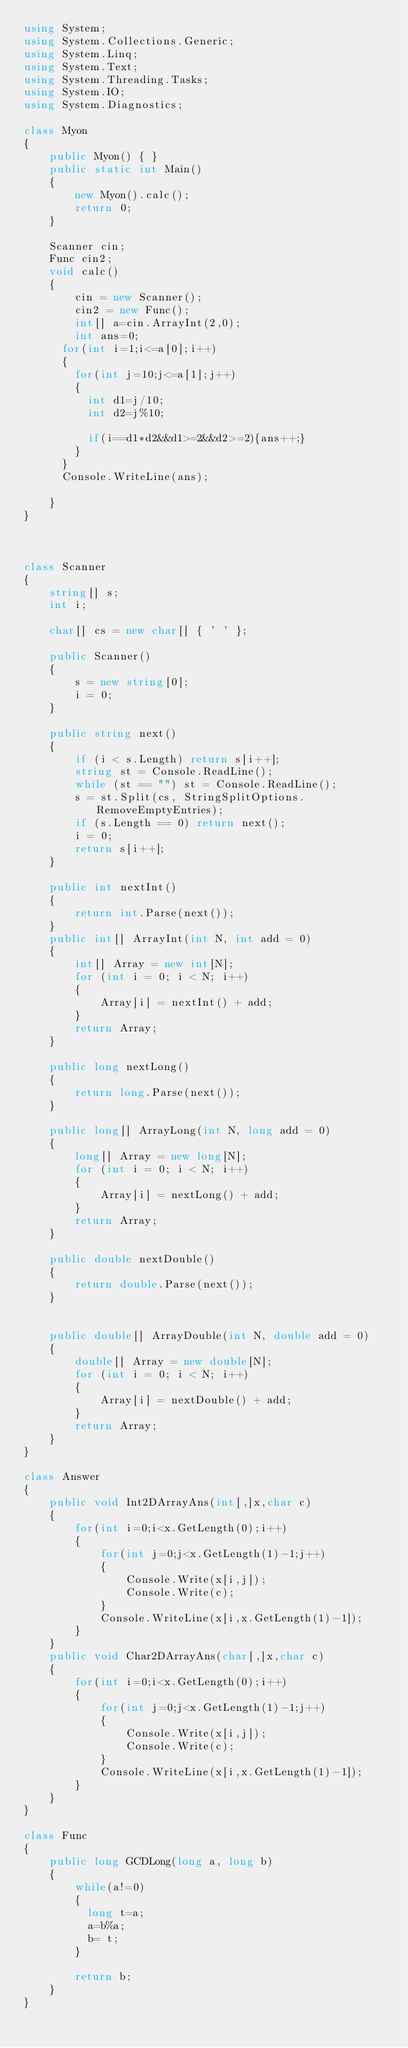Convert code to text. <code><loc_0><loc_0><loc_500><loc_500><_C#_>using System;
using System.Collections.Generic;
using System.Linq;
using System.Text;
using System.Threading.Tasks;
using System.IO;
using System.Diagnostics;

class Myon
{
    public Myon() { }
    public static int Main()
    {
        new Myon().calc();
        return 0;
    }

    Scanner cin;
    Func cin2;
    void calc()
    {
        cin = new Scanner();
        cin2 = new Func();
        int[] a=cin.ArrayInt(2,0);
        int ans=0;
      for(int i=1;i<=a[0];i++)
      {
        for(int j=10;j<=a[1];j++)
        {
          int d1=j/10;
          int d2=j%10;
          
          if(i==d1*d2&&d1>=2&&d2>=2){ans++;}
        }
      }
      Console.WriteLine(ans);
        
    }
}



class Scanner
{
    string[] s;
    int i;

    char[] cs = new char[] { ' ' };

    public Scanner()
    {
        s = new string[0];
        i = 0;
    }

    public string next()
    {
        if (i < s.Length) return s[i++];
        string st = Console.ReadLine();
        while (st == "") st = Console.ReadLine();
        s = st.Split(cs, StringSplitOptions.RemoveEmptyEntries);
        if (s.Length == 0) return next();
        i = 0;
        return s[i++];
    }

    public int nextInt()
    {
        return int.Parse(next());
    }
    public int[] ArrayInt(int N, int add = 0)
    {
        int[] Array = new int[N];
        for (int i = 0; i < N; i++)
        {
            Array[i] = nextInt() + add;
        }
        return Array;
    }

    public long nextLong()
    {
        return long.Parse(next());
    }

    public long[] ArrayLong(int N, long add = 0)
    {
        long[] Array = new long[N];
        for (int i = 0; i < N; i++)
        {
            Array[i] = nextLong() + add;
        }
        return Array;
    }

    public double nextDouble()
    {
        return double.Parse(next());
    }


    public double[] ArrayDouble(int N, double add = 0)
    {
        double[] Array = new double[N];
        for (int i = 0; i < N; i++)
        {
            Array[i] = nextDouble() + add;
        }
        return Array;
    }
}

class Answer
{
    public void Int2DArrayAns(int[,]x,char c)
    {
        for(int i=0;i<x.GetLength(0);i++)
        {
            for(int j=0;j<x.GetLength(1)-1;j++)
            {
                Console.Write(x[i,j]);
                Console.Write(c);
            }
            Console.WriteLine(x[i,x.GetLength(1)-1]);
        }
    }
    public void Char2DArrayAns(char[,]x,char c)
    {
        for(int i=0;i<x.GetLength(0);i++)
        {
            for(int j=0;j<x.GetLength(1)-1;j++)
            {
                Console.Write(x[i,j]);
                Console.Write(c);
            }
            Console.WriteLine(x[i,x.GetLength(1)-1]);
        }
    }
}

class Func
{
    public long GCDLong(long a, long b)
    {
        while(a!=0)
        {
          long t=a;
          a=b%a;
          b= t;
        }
      
        return b;        
    }
}</code> 